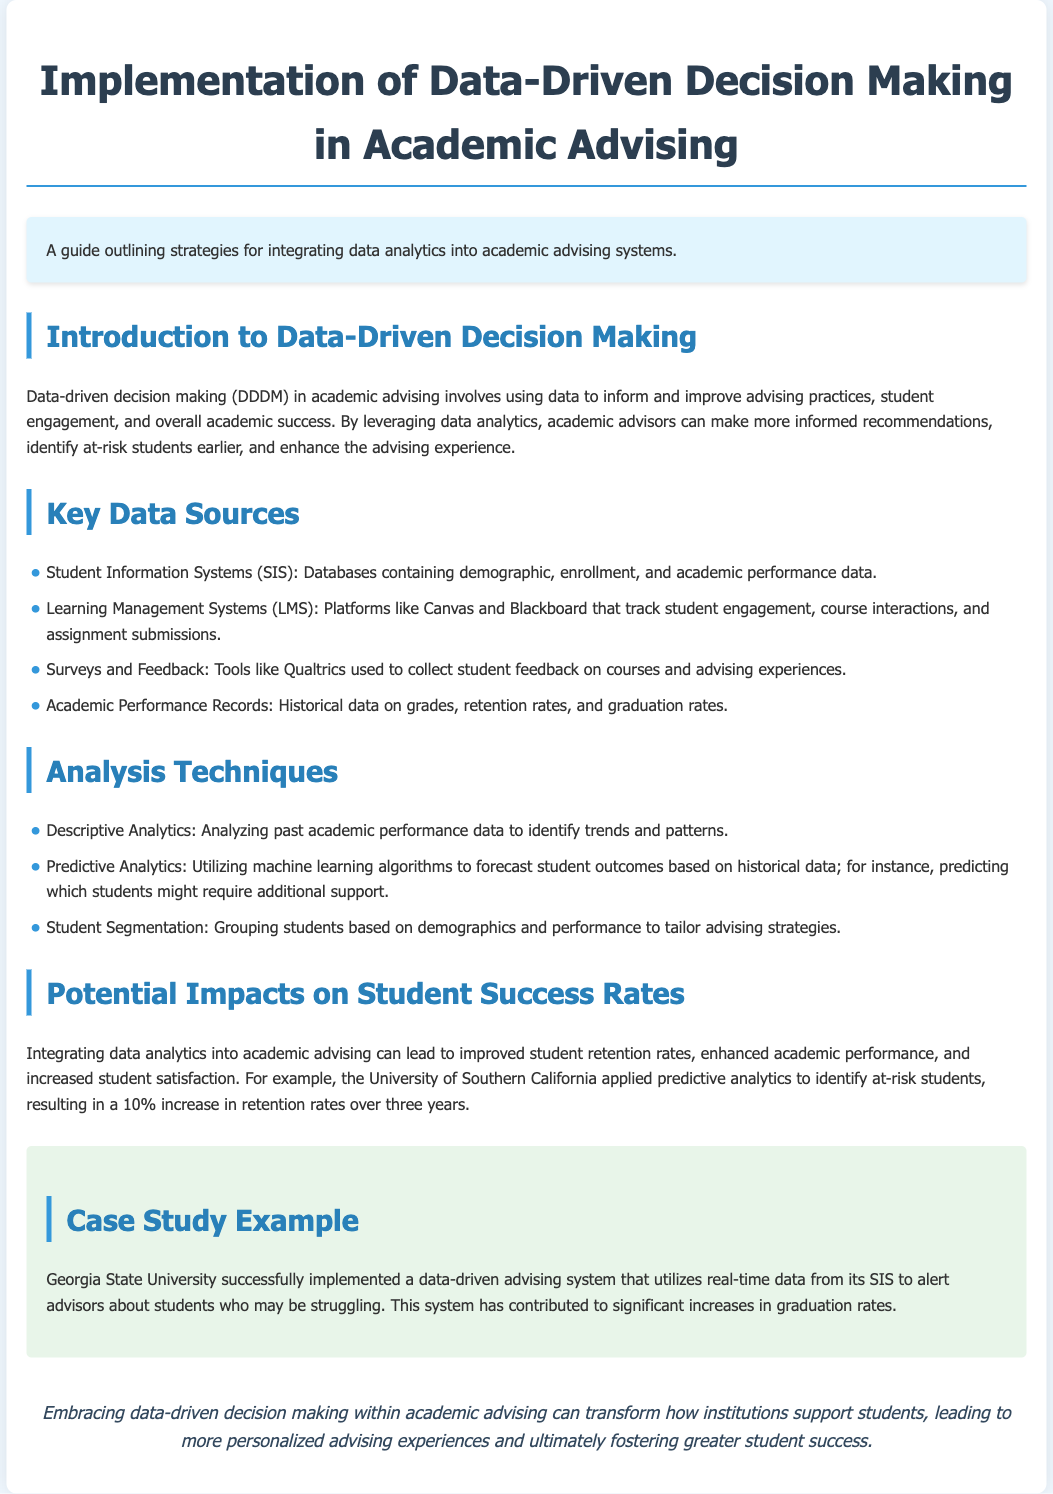what is the title of the document? The title is provided in the heading section of the document.
Answer: Implementation of Data-Driven Decision Making in Academic Advising what does DDDM stand for? DDDM is introduced at the beginning of the document and stands for Data-Driven Decision Making.
Answer: Data-Driven Decision Making which university applied predictive analytics to improve retention rates? The name of the university is mentioned in the section discussing potential impacts on student success rates.
Answer: University of Southern California what techniques are used to analyze student data? The document lists various analysis techniques under a dedicated section, describing them briefly.
Answer: Descriptive Analytics, Predictive Analytics, Student Segmentation what is one outcome of Georgia State University's advising system? This outcome is described in the case study example that highlights the impact of their advising system.
Answer: Increases in graduation rates how does data analytics improve advising practices? The improvement is discussed in the introduction and reflects on the benefits of using data analytics in advising.
Answer: Informed recommendations, identify at-risk students, enhance advising experience how much did retention rates increase after the predictive analytics implementation at USC? This statistic is found in the section discussing the potential impacts on student success rates.
Answer: 10% what are two key data sources mentioned? The document provides a list of data sources useful for academic advising.
Answer: Student Information Systems, Learning Management Systems 